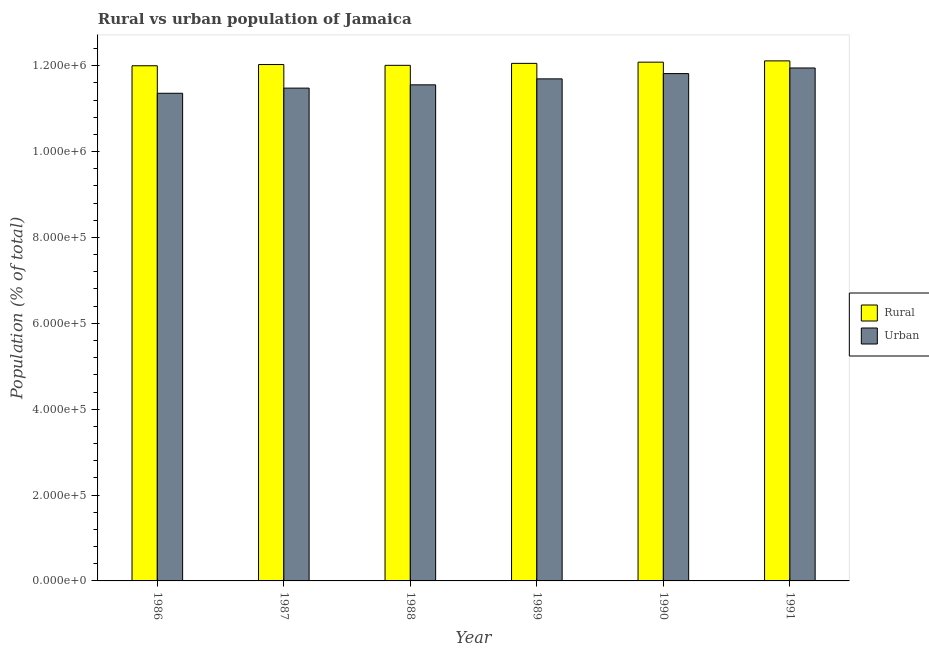What is the label of the 2nd group of bars from the left?
Make the answer very short. 1987. In how many cases, is the number of bars for a given year not equal to the number of legend labels?
Your response must be concise. 0. What is the urban population density in 1988?
Your response must be concise. 1.16e+06. Across all years, what is the maximum rural population density?
Keep it short and to the point. 1.21e+06. Across all years, what is the minimum urban population density?
Keep it short and to the point. 1.14e+06. In which year was the urban population density minimum?
Your response must be concise. 1986. What is the total rural population density in the graph?
Your answer should be compact. 7.23e+06. What is the difference between the urban population density in 1987 and that in 1990?
Offer a very short reply. -3.39e+04. What is the difference between the urban population density in 1986 and the rural population density in 1987?
Provide a short and direct response. -1.20e+04. What is the average rural population density per year?
Provide a short and direct response. 1.20e+06. In how many years, is the rural population density greater than 600000 %?
Ensure brevity in your answer.  6. What is the ratio of the rural population density in 1986 to that in 1987?
Offer a terse response. 1. Is the difference between the rural population density in 1987 and 1990 greater than the difference between the urban population density in 1987 and 1990?
Offer a terse response. No. What is the difference between the highest and the second highest urban population density?
Provide a succinct answer. 1.30e+04. What is the difference between the highest and the lowest rural population density?
Keep it short and to the point. 1.14e+04. In how many years, is the rural population density greater than the average rural population density taken over all years?
Your response must be concise. 3. Is the sum of the urban population density in 1986 and 1990 greater than the maximum rural population density across all years?
Offer a very short reply. Yes. What does the 2nd bar from the left in 1987 represents?
Make the answer very short. Urban. What does the 2nd bar from the right in 1986 represents?
Provide a succinct answer. Rural. How many bars are there?
Your response must be concise. 12. Does the graph contain grids?
Your response must be concise. No. Where does the legend appear in the graph?
Make the answer very short. Center right. How are the legend labels stacked?
Offer a terse response. Vertical. What is the title of the graph?
Your answer should be compact. Rural vs urban population of Jamaica. Does "Revenue" appear as one of the legend labels in the graph?
Provide a short and direct response. No. What is the label or title of the Y-axis?
Ensure brevity in your answer.  Population (% of total). What is the Population (% of total) in Rural in 1986?
Offer a very short reply. 1.20e+06. What is the Population (% of total) of Urban in 1986?
Offer a very short reply. 1.14e+06. What is the Population (% of total) in Rural in 1987?
Your response must be concise. 1.20e+06. What is the Population (% of total) in Urban in 1987?
Ensure brevity in your answer.  1.15e+06. What is the Population (% of total) of Rural in 1988?
Your answer should be very brief. 1.20e+06. What is the Population (% of total) of Urban in 1988?
Provide a succinct answer. 1.16e+06. What is the Population (% of total) of Rural in 1989?
Your answer should be compact. 1.21e+06. What is the Population (% of total) in Urban in 1989?
Your response must be concise. 1.17e+06. What is the Population (% of total) in Rural in 1990?
Your answer should be very brief. 1.21e+06. What is the Population (% of total) in Urban in 1990?
Offer a terse response. 1.18e+06. What is the Population (% of total) in Rural in 1991?
Provide a short and direct response. 1.21e+06. What is the Population (% of total) in Urban in 1991?
Your response must be concise. 1.19e+06. Across all years, what is the maximum Population (% of total) of Rural?
Provide a short and direct response. 1.21e+06. Across all years, what is the maximum Population (% of total) of Urban?
Your response must be concise. 1.19e+06. Across all years, what is the minimum Population (% of total) of Rural?
Your response must be concise. 1.20e+06. Across all years, what is the minimum Population (% of total) of Urban?
Provide a short and direct response. 1.14e+06. What is the total Population (% of total) of Rural in the graph?
Ensure brevity in your answer.  7.23e+06. What is the total Population (% of total) in Urban in the graph?
Ensure brevity in your answer.  6.99e+06. What is the difference between the Population (% of total) of Rural in 1986 and that in 1987?
Offer a terse response. -2808. What is the difference between the Population (% of total) in Urban in 1986 and that in 1987?
Your answer should be compact. -1.20e+04. What is the difference between the Population (% of total) of Rural in 1986 and that in 1988?
Make the answer very short. -969. What is the difference between the Population (% of total) of Urban in 1986 and that in 1988?
Give a very brief answer. -1.96e+04. What is the difference between the Population (% of total) in Rural in 1986 and that in 1989?
Offer a terse response. -5552. What is the difference between the Population (% of total) of Urban in 1986 and that in 1989?
Your response must be concise. -3.35e+04. What is the difference between the Population (% of total) in Rural in 1986 and that in 1990?
Offer a terse response. -8341. What is the difference between the Population (% of total) of Urban in 1986 and that in 1990?
Give a very brief answer. -4.59e+04. What is the difference between the Population (% of total) in Rural in 1986 and that in 1991?
Ensure brevity in your answer.  -1.14e+04. What is the difference between the Population (% of total) of Urban in 1986 and that in 1991?
Keep it short and to the point. -5.89e+04. What is the difference between the Population (% of total) of Rural in 1987 and that in 1988?
Your answer should be very brief. 1839. What is the difference between the Population (% of total) of Urban in 1987 and that in 1988?
Provide a succinct answer. -7639. What is the difference between the Population (% of total) in Rural in 1987 and that in 1989?
Your answer should be very brief. -2744. What is the difference between the Population (% of total) in Urban in 1987 and that in 1989?
Provide a succinct answer. -2.16e+04. What is the difference between the Population (% of total) in Rural in 1987 and that in 1990?
Offer a terse response. -5533. What is the difference between the Population (% of total) in Urban in 1987 and that in 1990?
Give a very brief answer. -3.39e+04. What is the difference between the Population (% of total) in Rural in 1987 and that in 1991?
Ensure brevity in your answer.  -8543. What is the difference between the Population (% of total) in Urban in 1987 and that in 1991?
Provide a short and direct response. -4.69e+04. What is the difference between the Population (% of total) of Rural in 1988 and that in 1989?
Provide a short and direct response. -4583. What is the difference between the Population (% of total) of Urban in 1988 and that in 1989?
Your answer should be very brief. -1.39e+04. What is the difference between the Population (% of total) of Rural in 1988 and that in 1990?
Ensure brevity in your answer.  -7372. What is the difference between the Population (% of total) of Urban in 1988 and that in 1990?
Your answer should be compact. -2.62e+04. What is the difference between the Population (% of total) of Rural in 1988 and that in 1991?
Give a very brief answer. -1.04e+04. What is the difference between the Population (% of total) in Urban in 1988 and that in 1991?
Give a very brief answer. -3.93e+04. What is the difference between the Population (% of total) in Rural in 1989 and that in 1990?
Keep it short and to the point. -2789. What is the difference between the Population (% of total) in Urban in 1989 and that in 1990?
Your answer should be very brief. -1.23e+04. What is the difference between the Population (% of total) in Rural in 1989 and that in 1991?
Provide a short and direct response. -5799. What is the difference between the Population (% of total) in Urban in 1989 and that in 1991?
Make the answer very short. -2.53e+04. What is the difference between the Population (% of total) of Rural in 1990 and that in 1991?
Give a very brief answer. -3010. What is the difference between the Population (% of total) of Urban in 1990 and that in 1991?
Provide a succinct answer. -1.30e+04. What is the difference between the Population (% of total) in Rural in 1986 and the Population (% of total) in Urban in 1987?
Give a very brief answer. 5.21e+04. What is the difference between the Population (% of total) in Rural in 1986 and the Population (% of total) in Urban in 1988?
Offer a terse response. 4.45e+04. What is the difference between the Population (% of total) in Rural in 1986 and the Population (% of total) in Urban in 1989?
Make the answer very short. 3.05e+04. What is the difference between the Population (% of total) of Rural in 1986 and the Population (% of total) of Urban in 1990?
Provide a short and direct response. 1.82e+04. What is the difference between the Population (% of total) of Rural in 1986 and the Population (% of total) of Urban in 1991?
Ensure brevity in your answer.  5203. What is the difference between the Population (% of total) in Rural in 1987 and the Population (% of total) in Urban in 1988?
Give a very brief answer. 4.73e+04. What is the difference between the Population (% of total) in Rural in 1987 and the Population (% of total) in Urban in 1989?
Your answer should be very brief. 3.34e+04. What is the difference between the Population (% of total) in Rural in 1987 and the Population (% of total) in Urban in 1990?
Offer a very short reply. 2.10e+04. What is the difference between the Population (% of total) of Rural in 1987 and the Population (% of total) of Urban in 1991?
Your answer should be very brief. 8011. What is the difference between the Population (% of total) of Rural in 1988 and the Population (% of total) of Urban in 1989?
Ensure brevity in your answer.  3.15e+04. What is the difference between the Population (% of total) of Rural in 1988 and the Population (% of total) of Urban in 1990?
Provide a short and direct response. 1.92e+04. What is the difference between the Population (% of total) in Rural in 1988 and the Population (% of total) in Urban in 1991?
Offer a very short reply. 6172. What is the difference between the Population (% of total) in Rural in 1989 and the Population (% of total) in Urban in 1990?
Make the answer very short. 2.38e+04. What is the difference between the Population (% of total) of Rural in 1989 and the Population (% of total) of Urban in 1991?
Give a very brief answer. 1.08e+04. What is the difference between the Population (% of total) of Rural in 1990 and the Population (% of total) of Urban in 1991?
Make the answer very short. 1.35e+04. What is the average Population (% of total) of Rural per year?
Your answer should be very brief. 1.20e+06. What is the average Population (% of total) in Urban per year?
Your answer should be very brief. 1.16e+06. In the year 1986, what is the difference between the Population (% of total) in Rural and Population (% of total) in Urban?
Provide a succinct answer. 6.41e+04. In the year 1987, what is the difference between the Population (% of total) of Rural and Population (% of total) of Urban?
Offer a terse response. 5.49e+04. In the year 1988, what is the difference between the Population (% of total) of Rural and Population (% of total) of Urban?
Provide a short and direct response. 4.54e+04. In the year 1989, what is the difference between the Population (% of total) in Rural and Population (% of total) in Urban?
Your answer should be very brief. 3.61e+04. In the year 1990, what is the difference between the Population (% of total) of Rural and Population (% of total) of Urban?
Your answer should be very brief. 2.66e+04. In the year 1991, what is the difference between the Population (% of total) in Rural and Population (% of total) in Urban?
Your answer should be compact. 1.66e+04. What is the ratio of the Population (% of total) in Urban in 1986 to that in 1987?
Offer a very short reply. 0.99. What is the ratio of the Population (% of total) in Rural in 1986 to that in 1988?
Keep it short and to the point. 1. What is the ratio of the Population (% of total) in Urban in 1986 to that in 1988?
Offer a terse response. 0.98. What is the ratio of the Population (% of total) of Rural in 1986 to that in 1989?
Make the answer very short. 1. What is the ratio of the Population (% of total) of Urban in 1986 to that in 1989?
Provide a succinct answer. 0.97. What is the ratio of the Population (% of total) in Rural in 1986 to that in 1990?
Give a very brief answer. 0.99. What is the ratio of the Population (% of total) of Urban in 1986 to that in 1990?
Your answer should be very brief. 0.96. What is the ratio of the Population (% of total) of Rural in 1986 to that in 1991?
Your answer should be very brief. 0.99. What is the ratio of the Population (% of total) of Urban in 1986 to that in 1991?
Keep it short and to the point. 0.95. What is the ratio of the Population (% of total) of Urban in 1987 to that in 1988?
Offer a very short reply. 0.99. What is the ratio of the Population (% of total) of Urban in 1987 to that in 1989?
Ensure brevity in your answer.  0.98. What is the ratio of the Population (% of total) of Urban in 1987 to that in 1990?
Offer a terse response. 0.97. What is the ratio of the Population (% of total) in Urban in 1987 to that in 1991?
Offer a terse response. 0.96. What is the ratio of the Population (% of total) in Rural in 1988 to that in 1989?
Provide a succinct answer. 1. What is the ratio of the Population (% of total) of Urban in 1988 to that in 1989?
Provide a succinct answer. 0.99. What is the ratio of the Population (% of total) in Rural in 1988 to that in 1990?
Provide a succinct answer. 0.99. What is the ratio of the Population (% of total) in Urban in 1988 to that in 1990?
Your answer should be compact. 0.98. What is the ratio of the Population (% of total) in Urban in 1988 to that in 1991?
Give a very brief answer. 0.97. What is the ratio of the Population (% of total) of Urban in 1989 to that in 1990?
Ensure brevity in your answer.  0.99. What is the ratio of the Population (% of total) in Urban in 1989 to that in 1991?
Give a very brief answer. 0.98. What is the ratio of the Population (% of total) in Rural in 1990 to that in 1991?
Ensure brevity in your answer.  1. What is the ratio of the Population (% of total) of Urban in 1990 to that in 1991?
Offer a very short reply. 0.99. What is the difference between the highest and the second highest Population (% of total) in Rural?
Your answer should be very brief. 3010. What is the difference between the highest and the second highest Population (% of total) in Urban?
Give a very brief answer. 1.30e+04. What is the difference between the highest and the lowest Population (% of total) in Rural?
Your answer should be compact. 1.14e+04. What is the difference between the highest and the lowest Population (% of total) in Urban?
Offer a terse response. 5.89e+04. 